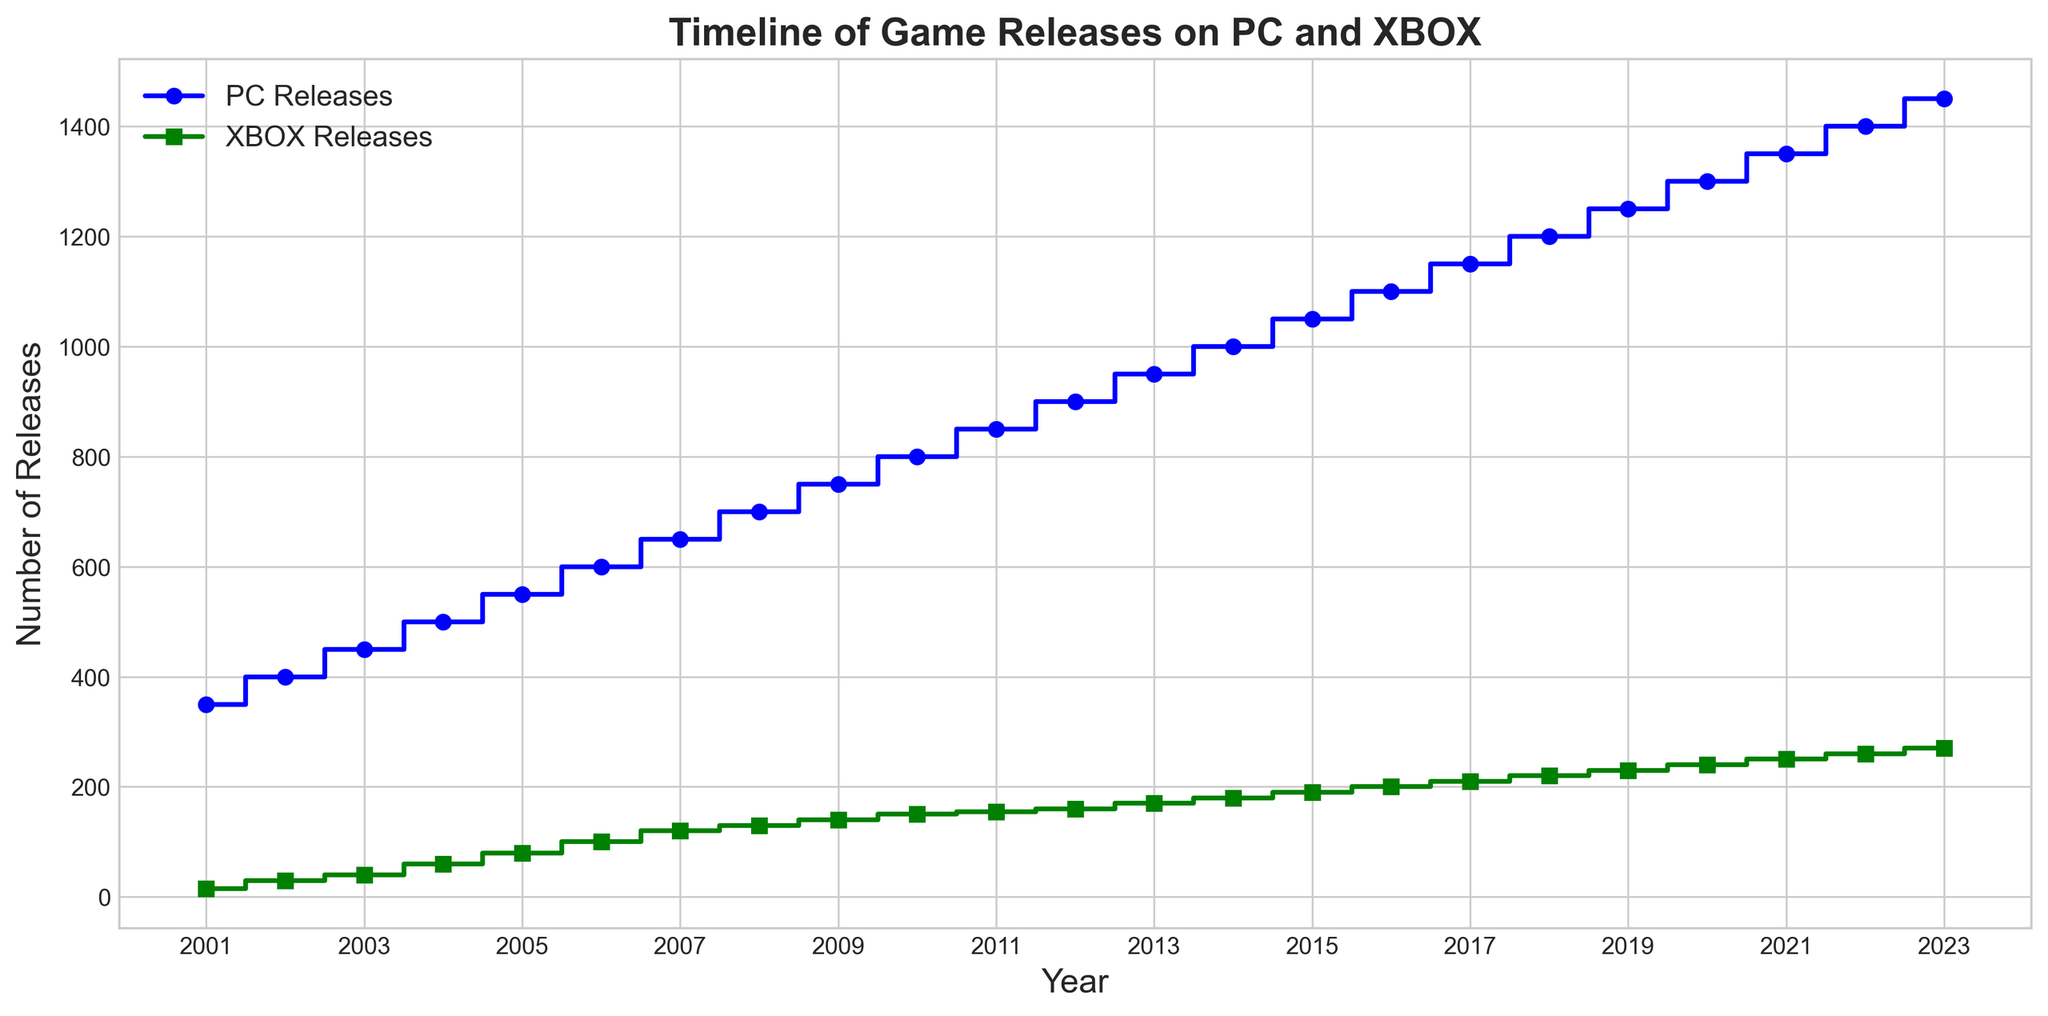Which platform had more game releases in 2010? From the figure, find the data points corresponding to the year 2010 on both the PC and XBOX release curves. PC releases were 800, and XBOX releases were 150. Since 800 > 150, PC had more releases.
Answer: PC What is the difference in the number of game releases between PC and XBOX in 2023? Locate the values for PC and XBOX in 2023 from the figure. PC had 1450 releases, and XBOX had 270 releases. The difference is 1450 - 270 = 1180.
Answer: 1180 How does the trend in game releases for PC compare to the trend for XBOX between 2008 and 2012? Examine the plot from 2008 to 2012. Both platforms show an increasing trend, but the PC releases grow at a higher rate compared to XBOX releases. Between 2008 and 2012, PC releases increased by 200 (from 700 to 900), whereas XBOX releases increased by 30 (from 130 to 160).
Answer: PC had a higher growth rate Which year saw XBOX reaching over 200 game releases for the first time? Look at the XBOX release curve and find the year when it first surpasses 200. This occurs in 2016 when XBOX releases reached 200.
Answer: 2016 What is the average number of PC game releases between 2001 and 2010? Identify the PC releases for each year from 2001 to 2010: 350, 400, 450, 500, 550, 600, 650, 700, 750, and 800. Sum these values (5250) and divide by the number of years (10). The average is 5250 / 10 = 525.
Answer: 525 Between 2016 and 2020, which platform had a higher increase in game releases? Calculate the difference in releases for both platforms between 2016 and 2020. For PC: 1300 - 1100 = 200. For XBOX: 240 - 200 = 40. Thus, PC had a higher increase.
Answer: PC What do the colors in the plot represent? Examine the legend of the figure to determine what the colors indicate. Blue is used for PC Releases, and green is used for XBOX Releases.
Answer: PC and XBOX platforms Between which years did PC game releases surpass 1000? Identify the point where the PC release curve surpasses 1000. PC releases exceed 1000 starting in 2014.
Answer: After 2014 What is the total number of XBOX releases from 2005 to 2010? Identify the XBOX releases for each year from 2005 to 2010: 80, 100, 120, 130, 140, and 150. Sum these values: 80 + 100 + 120 + 130 + 140 + 150 = 720.
Answer: 720 